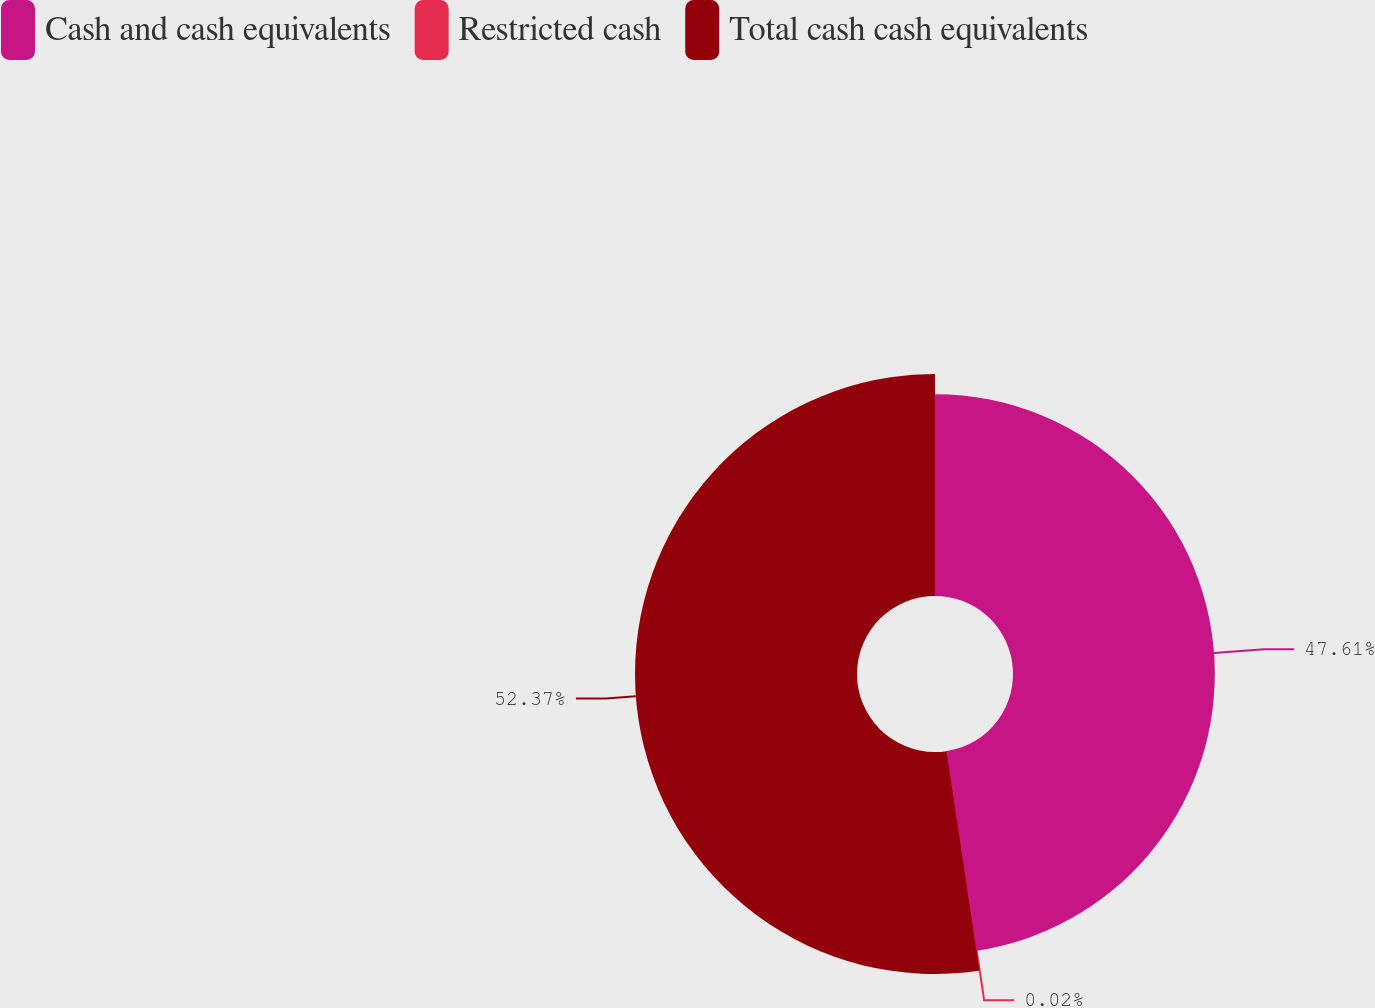Convert chart. <chart><loc_0><loc_0><loc_500><loc_500><pie_chart><fcel>Cash and cash equivalents<fcel>Restricted cash<fcel>Total cash cash equivalents<nl><fcel>47.61%<fcel>0.02%<fcel>52.37%<nl></chart> 